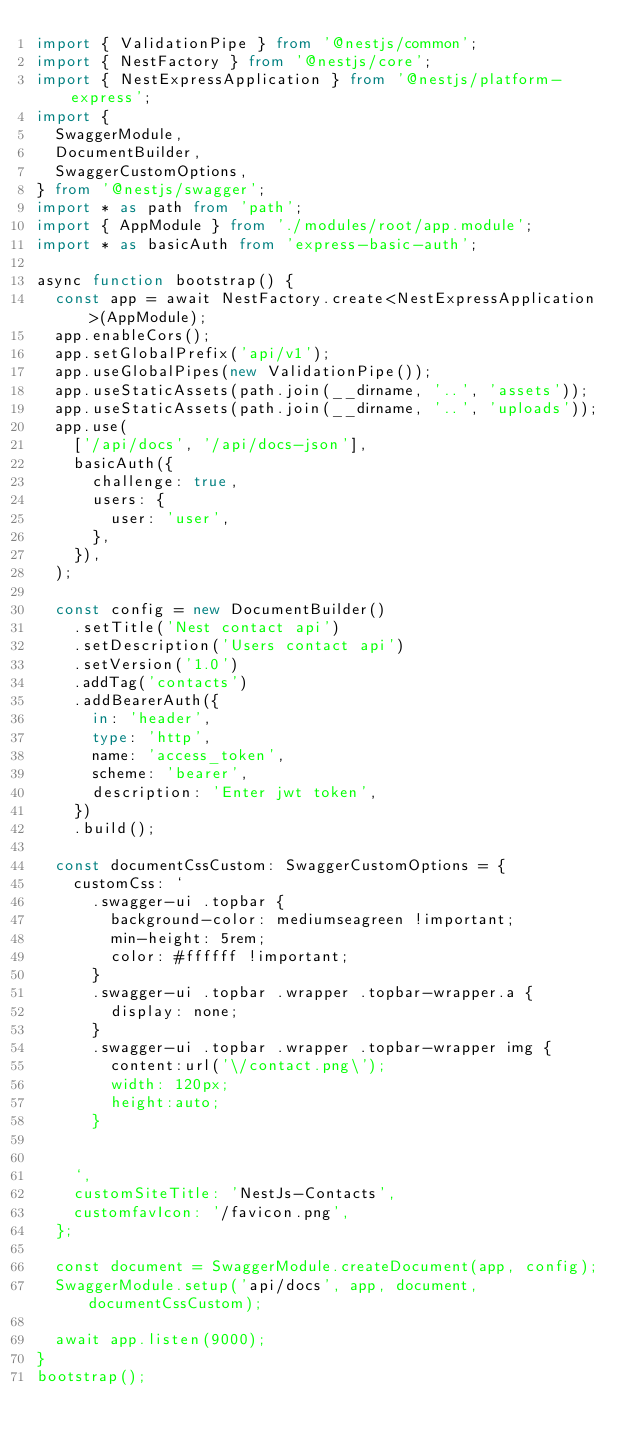<code> <loc_0><loc_0><loc_500><loc_500><_TypeScript_>import { ValidationPipe } from '@nestjs/common';
import { NestFactory } from '@nestjs/core';
import { NestExpressApplication } from '@nestjs/platform-express';
import {
  SwaggerModule,
  DocumentBuilder,
  SwaggerCustomOptions,
} from '@nestjs/swagger';
import * as path from 'path';
import { AppModule } from './modules/root/app.module';
import * as basicAuth from 'express-basic-auth';

async function bootstrap() {
  const app = await NestFactory.create<NestExpressApplication>(AppModule);
  app.enableCors();
  app.setGlobalPrefix('api/v1');
  app.useGlobalPipes(new ValidationPipe());
  app.useStaticAssets(path.join(__dirname, '..', 'assets'));
  app.useStaticAssets(path.join(__dirname, '..', 'uploads'));
  app.use(
    ['/api/docs', '/api/docs-json'],
    basicAuth({
      challenge: true,
      users: {
        user: 'user',
      },
    }),
  );

  const config = new DocumentBuilder()
    .setTitle('Nest contact api')
    .setDescription('Users contact api')
    .setVersion('1.0')
    .addTag('contacts')
    .addBearerAuth({
      in: 'header',
      type: 'http',
      name: 'access_token',
      scheme: 'bearer',
      description: 'Enter jwt token',
    })
    .build();

  const documentCssCustom: SwaggerCustomOptions = {
    customCss: `
      .swagger-ui .topbar { 
        background-color: mediumseagreen !important; 
        min-height: 5rem; 
        color: #ffffff !important; 
      }
      .swagger-ui .topbar .wrapper .topbar-wrapper.a { 
        display: none; 
      }
      .swagger-ui .topbar .wrapper .topbar-wrapper img {
        content:url('\/contact.png\'); 
        width: 120px; 
        height:auto;        
      } 
     

    `,
    customSiteTitle: 'NestJs-Contacts',
    customfavIcon: '/favicon.png',
  };

  const document = SwaggerModule.createDocument(app, config);
  SwaggerModule.setup('api/docs', app, document, documentCssCustom);

  await app.listen(9000);
}
bootstrap();
</code> 